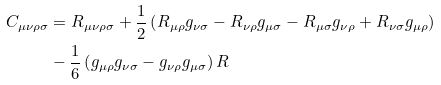<formula> <loc_0><loc_0><loc_500><loc_500>C _ { \mu \nu \rho \sigma } & = R _ { \mu \nu \rho \sigma } + \frac { 1 } { 2 } \left ( R _ { \mu \rho } g _ { \nu \sigma } - R _ { \nu \rho } g _ { \mu \sigma } - R _ { \mu \sigma } g _ { \nu \rho } + R _ { \nu \sigma } g _ { \mu \rho } \right ) \\ & - \frac { 1 } { 6 } \left ( g _ { \mu \rho } g _ { \nu \sigma } - g _ { \nu \rho } g _ { \mu \sigma } \right ) R</formula> 